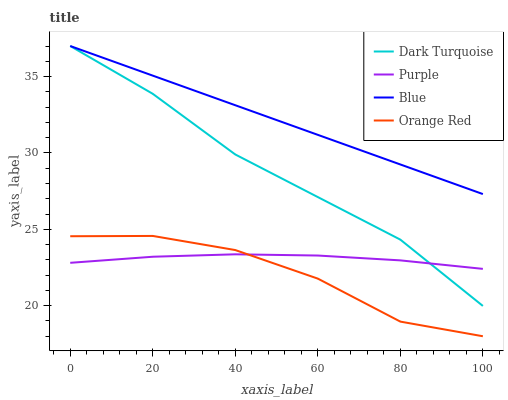Does Orange Red have the minimum area under the curve?
Answer yes or no. Yes. Does Blue have the maximum area under the curve?
Answer yes or no. Yes. Does Dark Turquoise have the minimum area under the curve?
Answer yes or no. No. Does Dark Turquoise have the maximum area under the curve?
Answer yes or no. No. Is Blue the smoothest?
Answer yes or no. Yes. Is Orange Red the roughest?
Answer yes or no. Yes. Is Dark Turquoise the smoothest?
Answer yes or no. No. Is Dark Turquoise the roughest?
Answer yes or no. No. Does Orange Red have the lowest value?
Answer yes or no. Yes. Does Dark Turquoise have the lowest value?
Answer yes or no. No. Does Blue have the highest value?
Answer yes or no. Yes. Does Orange Red have the highest value?
Answer yes or no. No. Is Purple less than Blue?
Answer yes or no. Yes. Is Blue greater than Orange Red?
Answer yes or no. Yes. Does Orange Red intersect Purple?
Answer yes or no. Yes. Is Orange Red less than Purple?
Answer yes or no. No. Is Orange Red greater than Purple?
Answer yes or no. No. Does Purple intersect Blue?
Answer yes or no. No. 